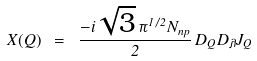<formula> <loc_0><loc_0><loc_500><loc_500>X ( Q ) \ = \ \frac { - i \sqrt { 3 } \, \pi ^ { 1 / 2 } N _ { n p } } 2 \, D _ { Q } D _ { \lambda } J _ { Q }</formula> 